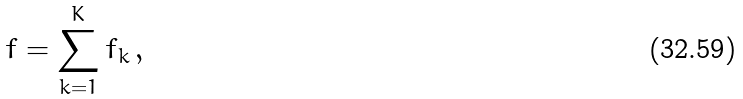Convert formula to latex. <formula><loc_0><loc_0><loc_500><loc_500>f = \sum _ { k = 1 } ^ { K } f _ { k } \, ,</formula> 